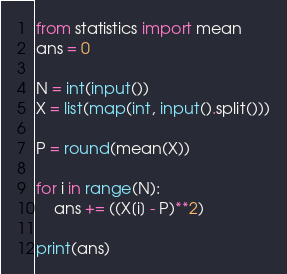<code> <loc_0><loc_0><loc_500><loc_500><_Python_>from statistics import mean
ans = 0

N = int(input())
X = list(map(int, input().split()))

P = round(mean(X))

for i in range(N):
    ans += ((X[i] - P)**2)

print(ans)</code> 